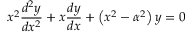Convert formula to latex. <formula><loc_0><loc_0><loc_500><loc_500>x ^ { 2 } { \frac { d ^ { 2 } y } { d x ^ { 2 } } } + x { \frac { d y } { d x } } + \left ( x ^ { 2 } - \alpha ^ { 2 } \right ) y = 0</formula> 